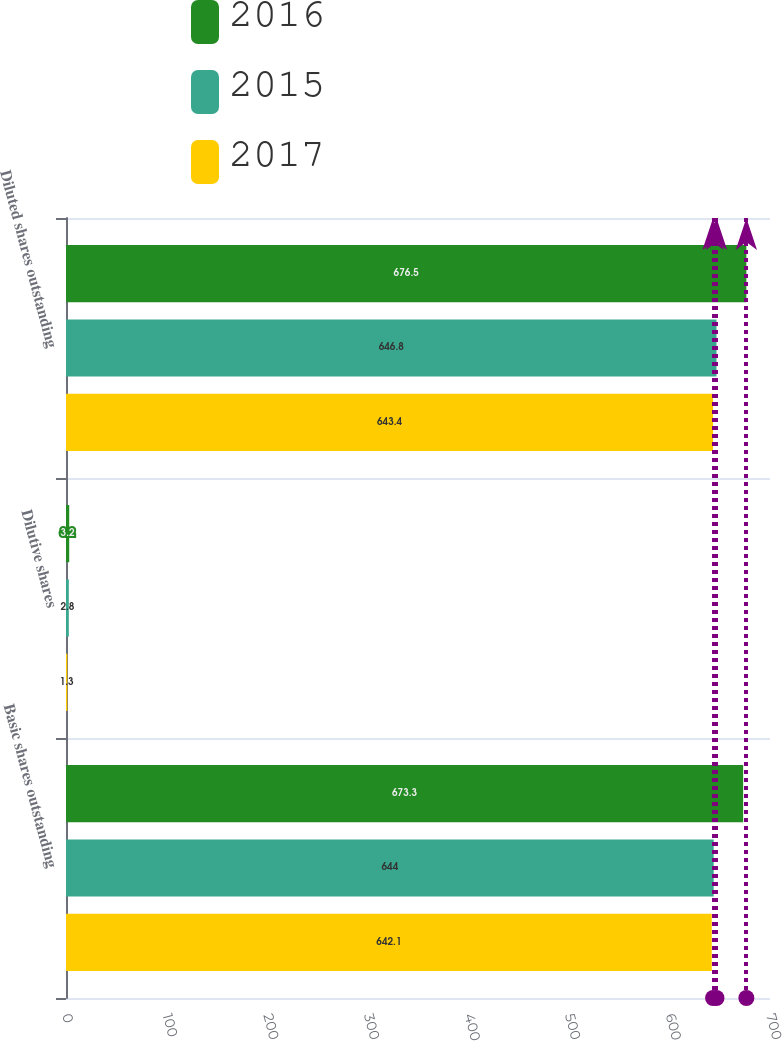Convert chart. <chart><loc_0><loc_0><loc_500><loc_500><stacked_bar_chart><ecel><fcel>Basic shares outstanding<fcel>Dilutive shares<fcel>Diluted shares outstanding<nl><fcel>2016<fcel>673.3<fcel>3.2<fcel>676.5<nl><fcel>2015<fcel>644<fcel>2.8<fcel>646.8<nl><fcel>2017<fcel>642.1<fcel>1.3<fcel>643.4<nl></chart> 